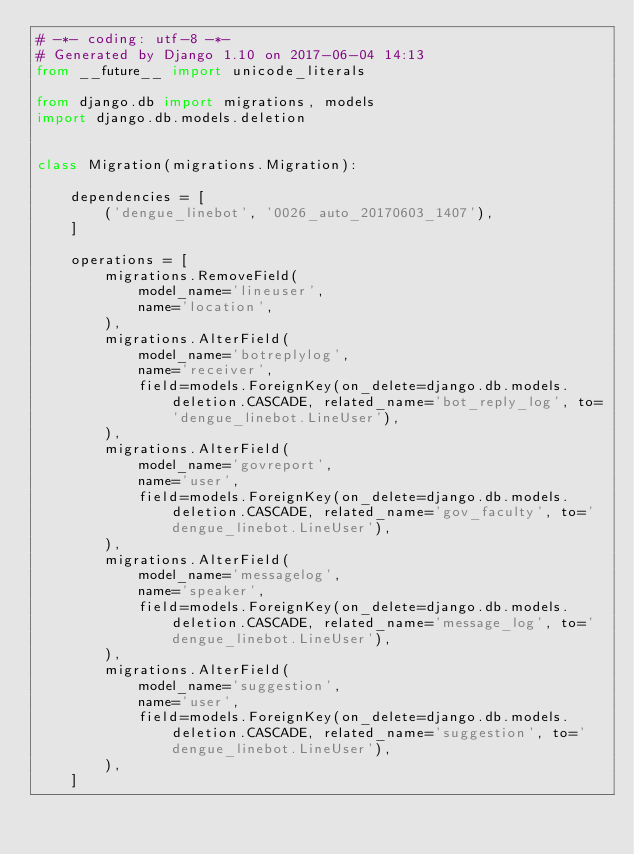Convert code to text. <code><loc_0><loc_0><loc_500><loc_500><_Python_># -*- coding: utf-8 -*-
# Generated by Django 1.10 on 2017-06-04 14:13
from __future__ import unicode_literals

from django.db import migrations, models
import django.db.models.deletion


class Migration(migrations.Migration):

    dependencies = [
        ('dengue_linebot', '0026_auto_20170603_1407'),
    ]

    operations = [
        migrations.RemoveField(
            model_name='lineuser',
            name='location',
        ),
        migrations.AlterField(
            model_name='botreplylog',
            name='receiver',
            field=models.ForeignKey(on_delete=django.db.models.deletion.CASCADE, related_name='bot_reply_log', to='dengue_linebot.LineUser'),
        ),
        migrations.AlterField(
            model_name='govreport',
            name='user',
            field=models.ForeignKey(on_delete=django.db.models.deletion.CASCADE, related_name='gov_faculty', to='dengue_linebot.LineUser'),
        ),
        migrations.AlterField(
            model_name='messagelog',
            name='speaker',
            field=models.ForeignKey(on_delete=django.db.models.deletion.CASCADE, related_name='message_log', to='dengue_linebot.LineUser'),
        ),
        migrations.AlterField(
            model_name='suggestion',
            name='user',
            field=models.ForeignKey(on_delete=django.db.models.deletion.CASCADE, related_name='suggestion', to='dengue_linebot.LineUser'),
        ),
    ]
</code> 